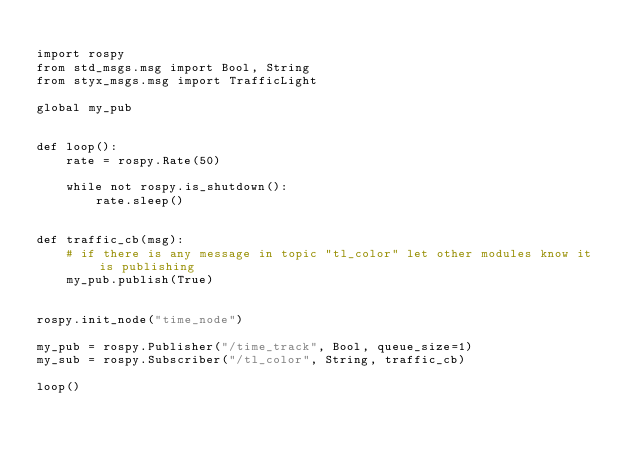<code> <loc_0><loc_0><loc_500><loc_500><_Python_>
import rospy
from std_msgs.msg import Bool, String
from styx_msgs.msg import TrafficLight

global my_pub


def loop():
    rate = rospy.Rate(50)
    
    while not rospy.is_shutdown():
        rate.sleep()


def traffic_cb(msg):
    # if there is any message in topic "tl_color" let other modules know it is publishing
    my_pub.publish(True)


rospy.init_node("time_node")

my_pub = rospy.Publisher("/time_track", Bool, queue_size=1)
my_sub = rospy.Subscriber("/tl_color", String, traffic_cb)

loop()</code> 